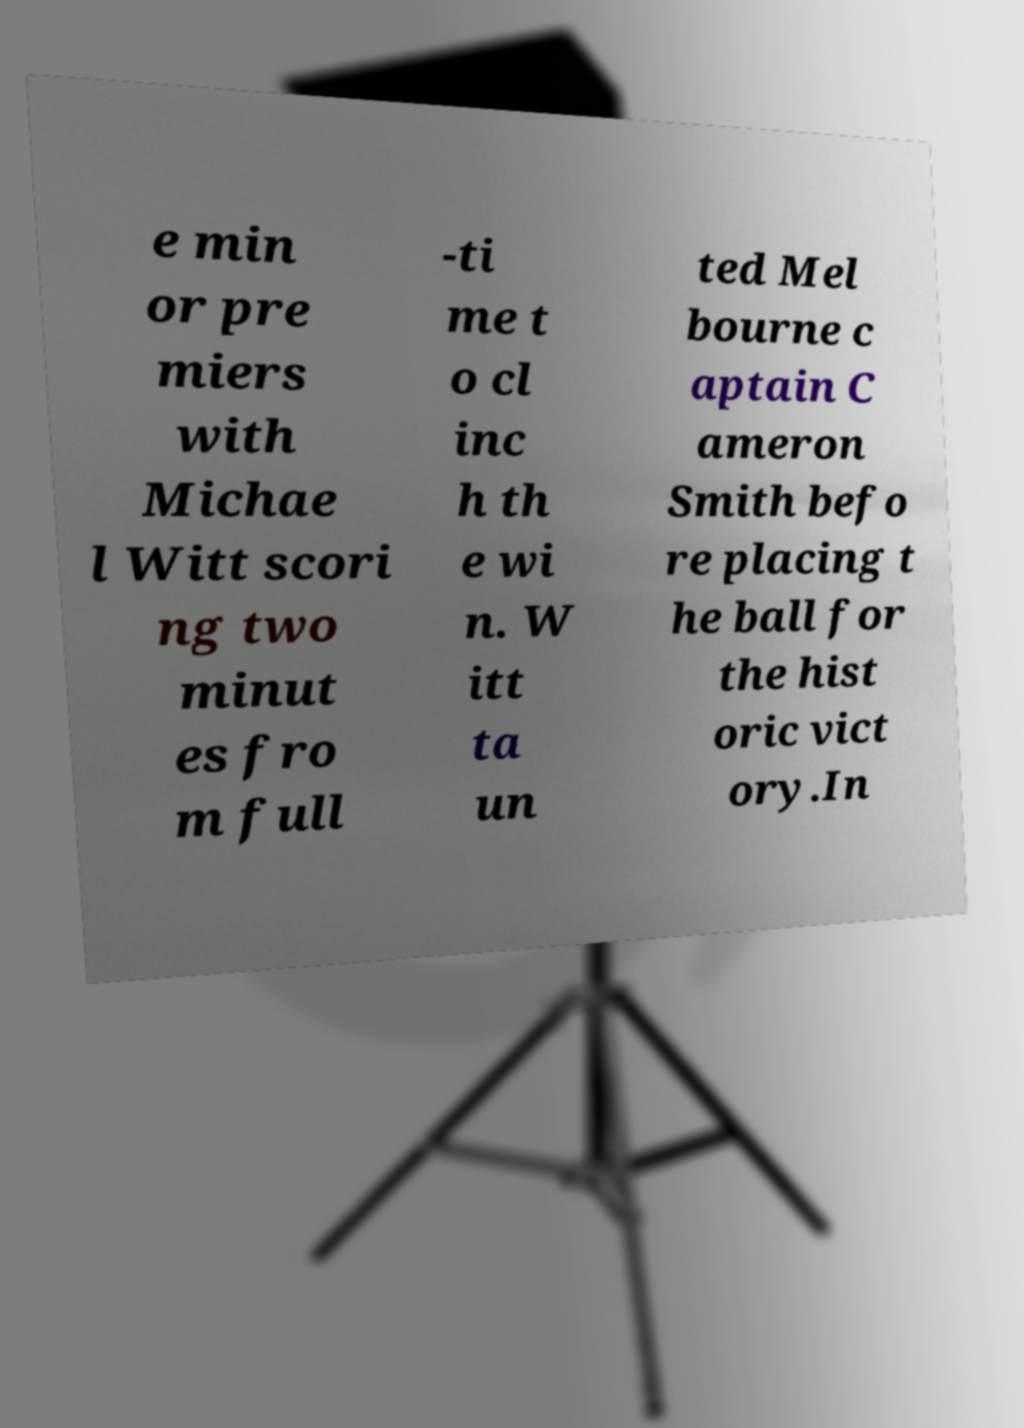Please read and relay the text visible in this image. What does it say? e min or pre miers with Michae l Witt scori ng two minut es fro m full -ti me t o cl inc h th e wi n. W itt ta un ted Mel bourne c aptain C ameron Smith befo re placing t he ball for the hist oric vict ory.In 